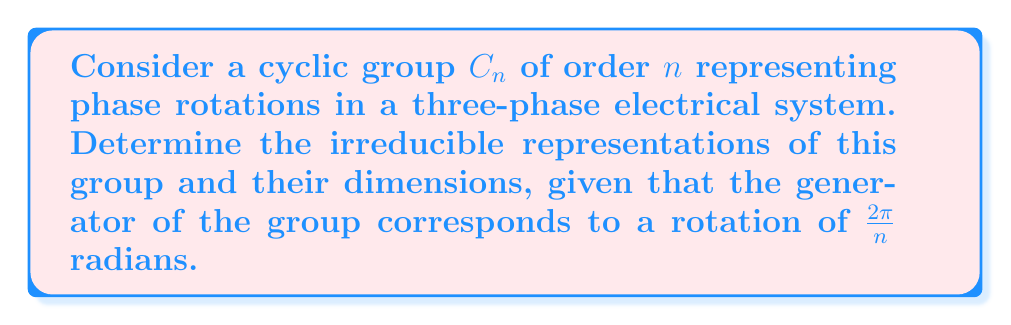Can you answer this question? To determine the irreducible representations of the cyclic group $C_n$, we follow these steps:

1) For a cyclic group $C_n$, all irreducible representations are one-dimensional. This is because $C_n$ is abelian, and all irreducible representations of abelian groups are one-dimensional.

2) The irreducible representations of $C_n$ are given by the characters $\chi_k: C_n \rightarrow \mathbb{C}^*$, where $k = 0, 1, ..., n-1$.

3) For the generator $g$ of $C_n$, which corresponds to a rotation of $\frac{2\pi}{n}$ radians, the characters are defined as:

   $$\chi_k(g) = e^{2\pi i k/n}$$

4) For a general element $g^m \in C_n$, the character is:

   $$\chi_k(g^m) = (e^{2\pi i k/n})^m = e^{2\pi i km/n}$$

5) Each of these characters $\chi_k$ defines a one-dimensional irreducible representation of $C_n$.

6) The number of irreducible representations is equal to the number of conjugacy classes in $C_n$. Since $C_n$ is abelian, each element forms its own conjugacy class, so there are $n$ irreducible representations.

In the context of a three-phase electrical system, these representations correspond to different phase rotations. For example, $\chi_1$ represents a rotation by $\frac{2\pi}{n}$, $\chi_2$ represents a rotation by $\frac{4\pi}{n}$, and so on.
Answer: $n$ one-dimensional irreducible representations given by $\chi_k(g^m) = e^{2\pi i km/n}$, where $k = 0, 1, ..., n-1$. 